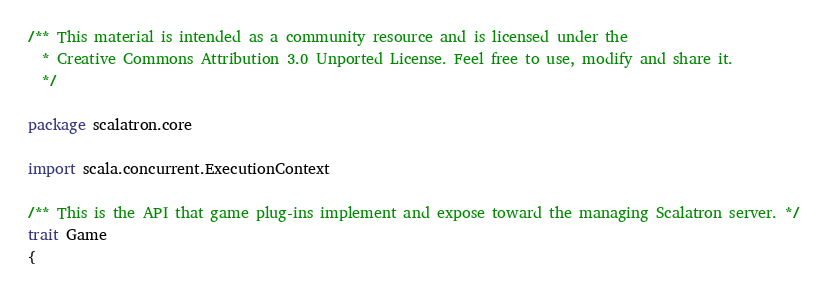Convert code to text. <code><loc_0><loc_0><loc_500><loc_500><_Scala_>/** This material is intended as a community resource and is licensed under the
  * Creative Commons Attribution 3.0 Unported License. Feel free to use, modify and share it.
  */

package scalatron.core

import scala.concurrent.ExecutionContext

/** This is the API that game plug-ins implement and expose toward the managing Scalatron server. */
trait Game
{</code> 